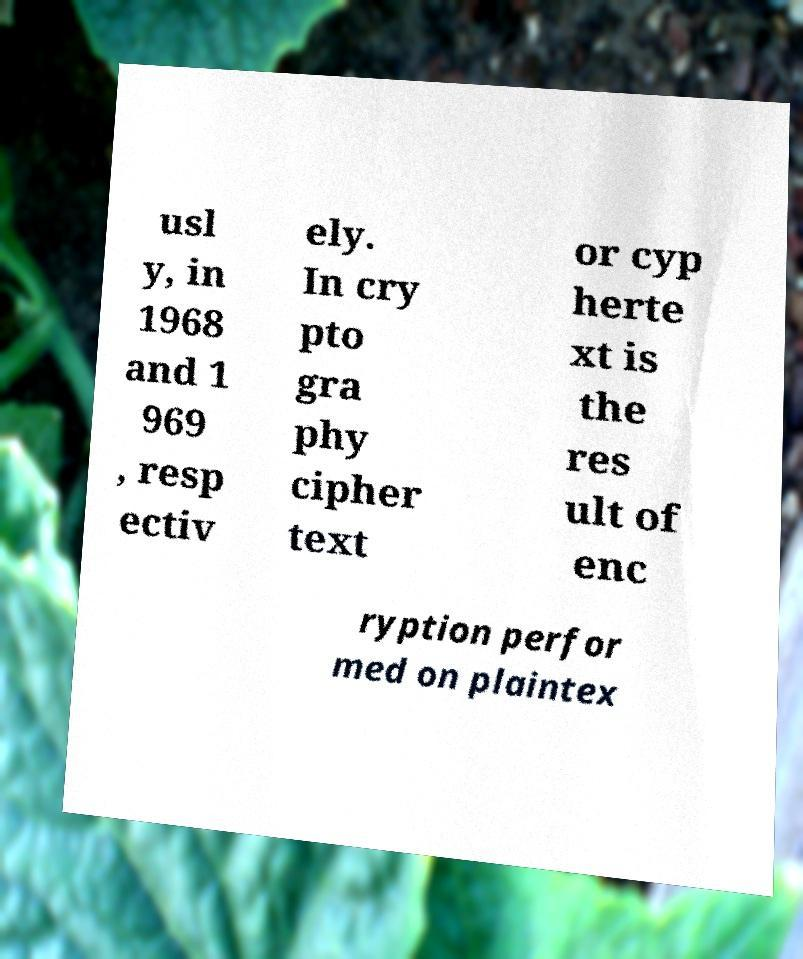Please identify and transcribe the text found in this image. usl y, in 1968 and 1 969 , resp ectiv ely. In cry pto gra phy cipher text or cyp herte xt is the res ult of enc ryption perfor med on plaintex 